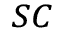Convert formula to latex. <formula><loc_0><loc_0><loc_500><loc_500>_ { S C }</formula> 